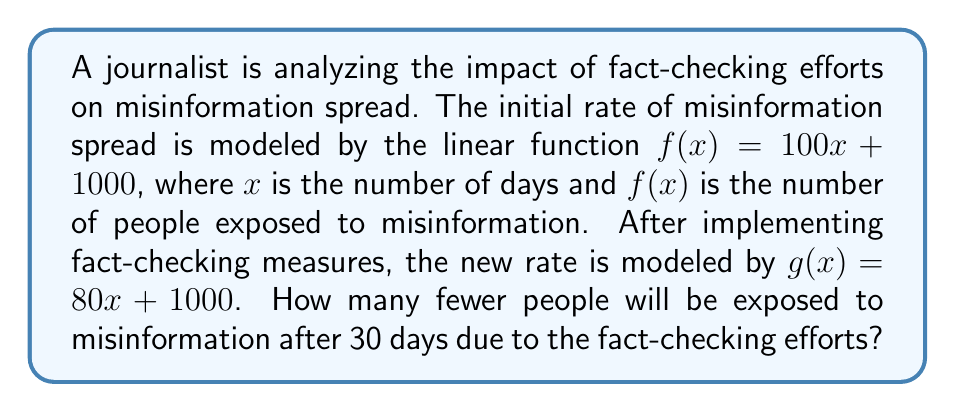Provide a solution to this math problem. 1. First, we need to calculate the number of people exposed to misinformation without fact-checking after 30 days:
   $f(30) = 100(30) + 1000 = 3000 + 1000 = 4000$ people

2. Next, we calculate the number of people exposed to misinformation with fact-checking after 30 days:
   $g(30) = 80(30) + 1000 = 2400 + 1000 = 3400$ people

3. To find the difference, we subtract the result of $g(30)$ from $f(30)$:
   $4000 - 3400 = 600$ people

Therefore, 600 fewer people will be exposed to misinformation after 30 days due to the fact-checking efforts.
Answer: 600 people 